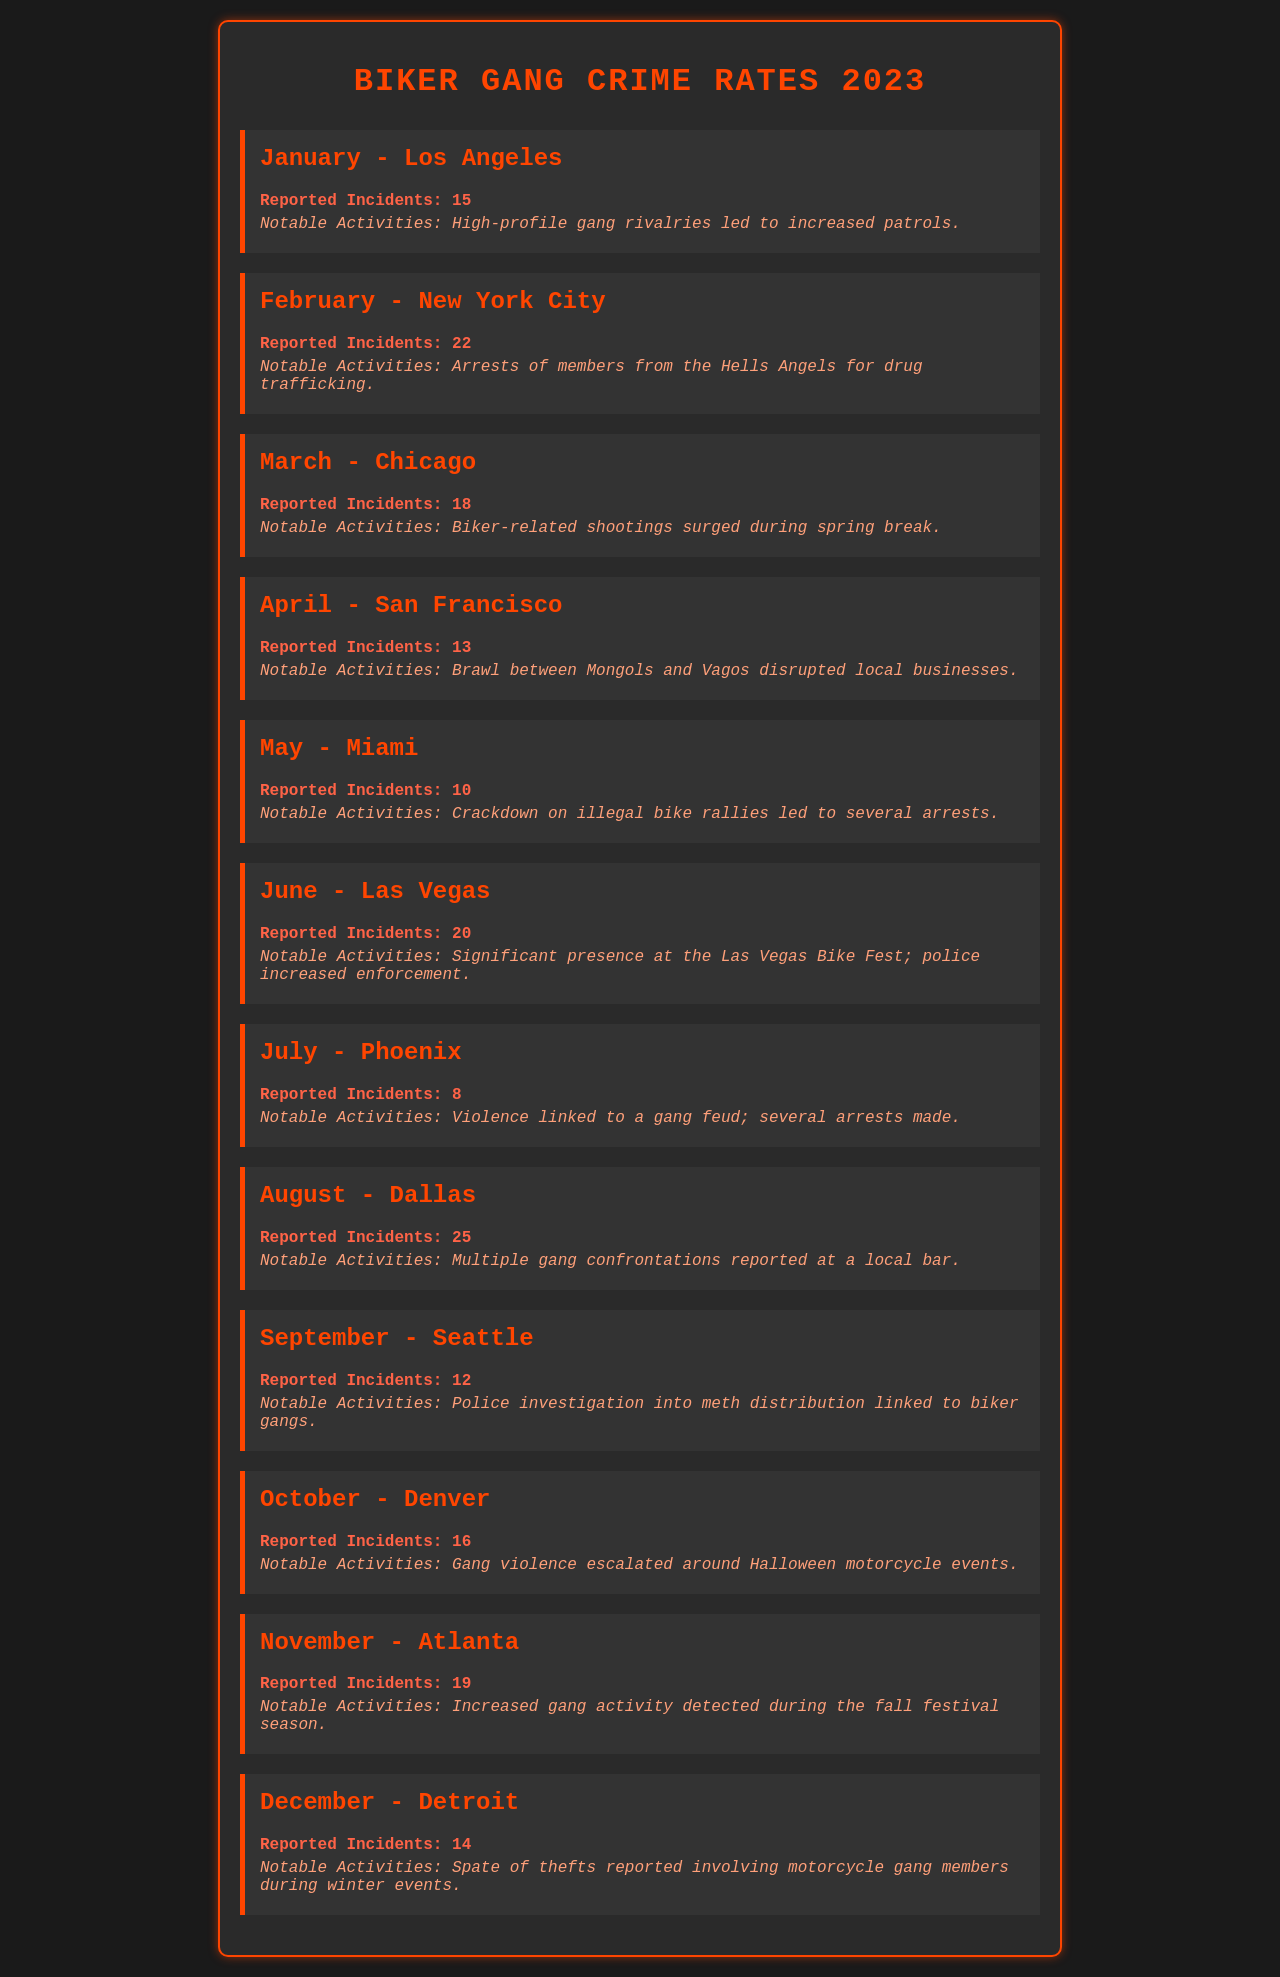What city reported the highest number of incidents in August? August listed Dallas as the city with the highest incidents, which were 25.
Answer: Dallas What notable activity was reported in June? The document states that a significant presence at the Las Vegas Bike Fest led to increased police enforcement.
Answer: Significant presence at the Las Vegas Bike Fest How many reported incidents occurred in July? The document lists 8 reported incidents for July in Phoenix.
Answer: 8 Which month saw the lowest reported incidents? July had the lowest reported incidents with just 8 in Phoenix.
Answer: 8 What was a notable activity in November? Increased gang activity was detected during the fall festival season.
Answer: Increased gang activity during the fall festival season How many reported incidents occurred in February? The document states that there were 22 reported incidents in New York City in February.
Answer: 22 Which city experienced a brawl between two gangs in April? The document mentions a brawl between Mongols and Vagos in San Francisco.
Answer: San Francisco What was the notable activity in March? The notable activity was a surge in biker-related shootings during spring break in Chicago.
Answer: Biker-related shootings surged during spring break 